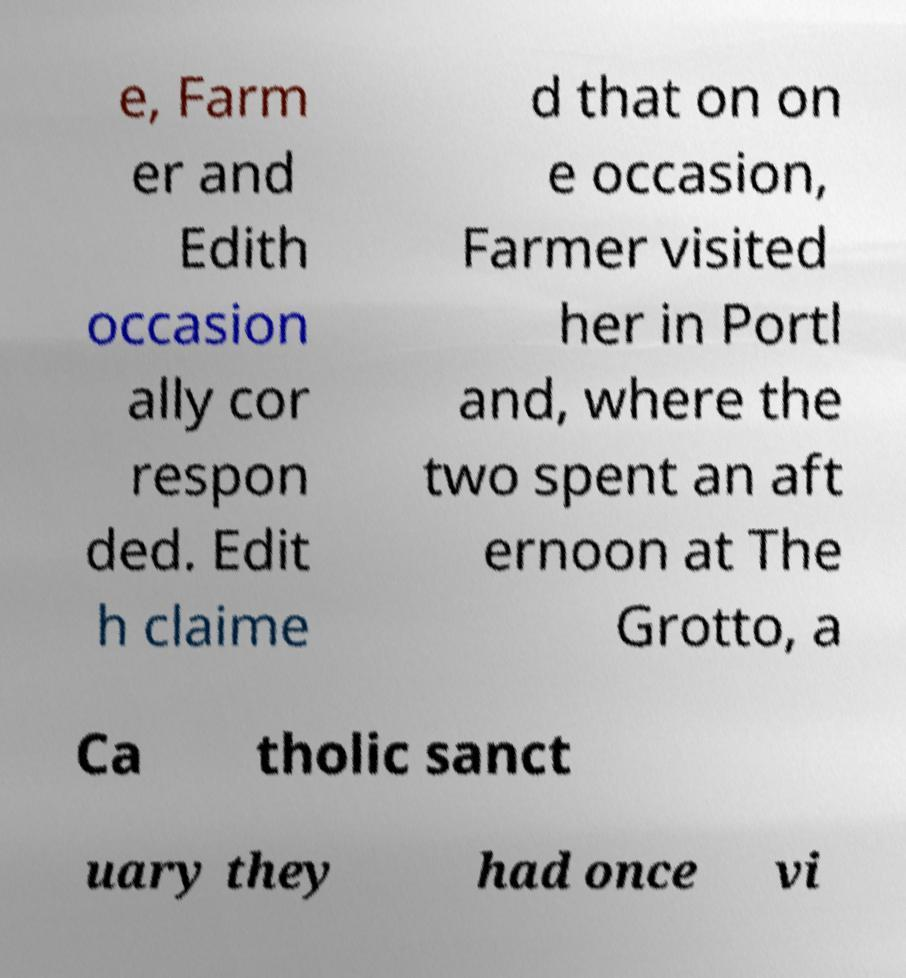For documentation purposes, I need the text within this image transcribed. Could you provide that? e, Farm er and Edith occasion ally cor respon ded. Edit h claime d that on on e occasion, Farmer visited her in Portl and, where the two spent an aft ernoon at The Grotto, a Ca tholic sanct uary they had once vi 